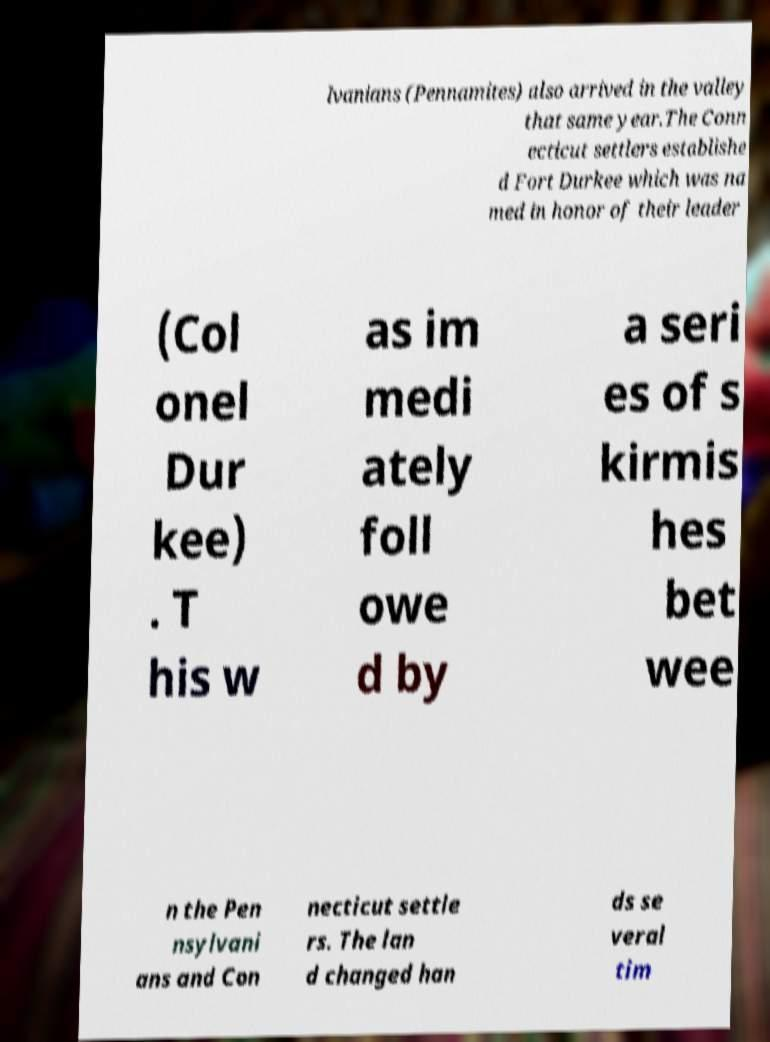Please identify and transcribe the text found in this image. lvanians (Pennamites) also arrived in the valley that same year.The Conn ecticut settlers establishe d Fort Durkee which was na med in honor of their leader (Col onel Dur kee) . T his w as im medi ately foll owe d by a seri es of s kirmis hes bet wee n the Pen nsylvani ans and Con necticut settle rs. The lan d changed han ds se veral tim 